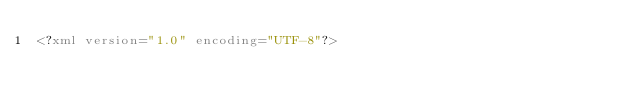<code> <loc_0><loc_0><loc_500><loc_500><_XML_><?xml version="1.0" encoding="UTF-8"?></code> 